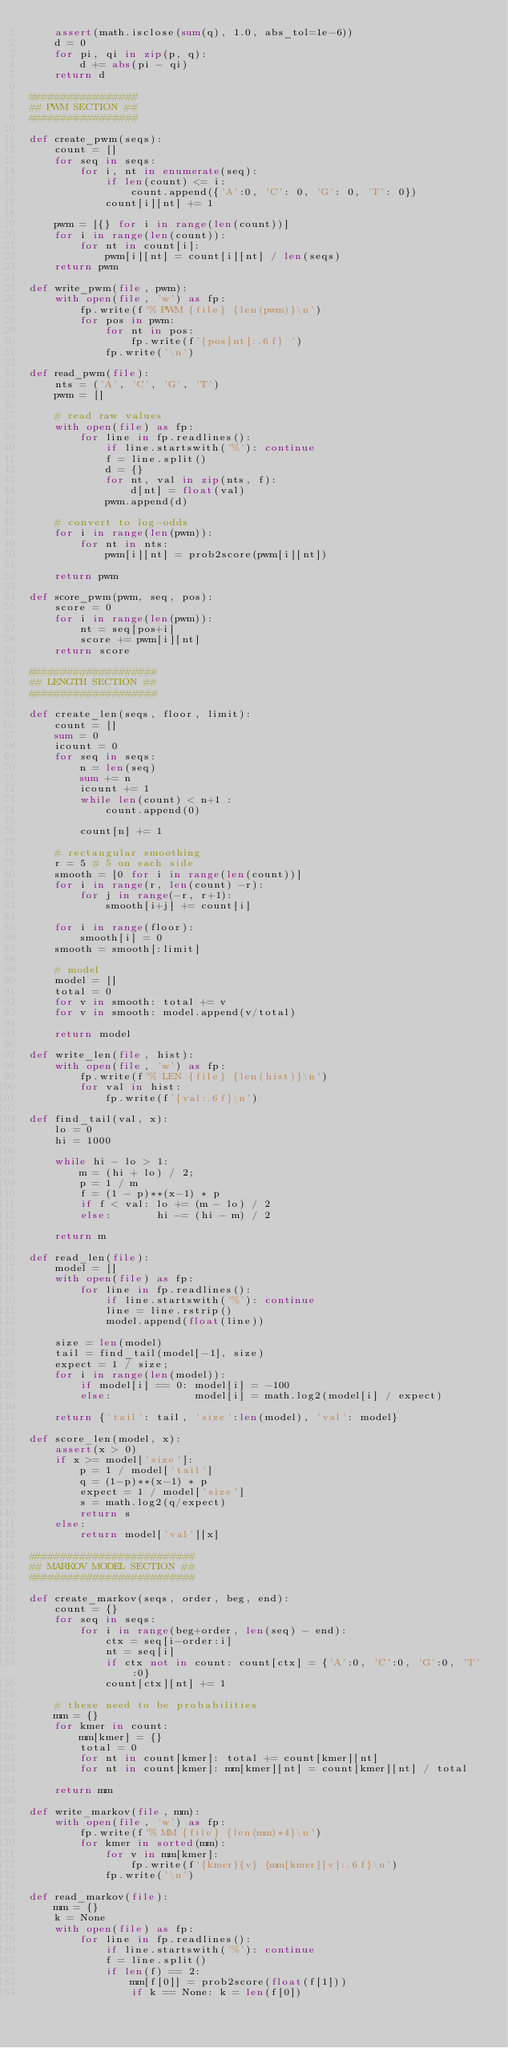Convert code to text. <code><loc_0><loc_0><loc_500><loc_500><_Python_>	assert(math.isclose(sum(q), 1.0, abs_tol=1e-6))
	d = 0
	for pi, qi in zip(p, q):
		d += abs(pi - qi)
	return d

#################
## PWM SECTION ##
#################

def create_pwm(seqs):
	count = []
	for seq in seqs:
		for i, nt in enumerate(seq):
			if len(count) <= i:
				count.append({'A':0, 'C': 0, 'G': 0, 'T': 0})
			count[i][nt] += 1

	pwm = [{} for i in range(len(count))]
	for i in range(len(count)):
		for nt in count[i]:
			pwm[i][nt] = count[i][nt] / len(seqs)
	return pwm

def write_pwm(file, pwm):
	with open(file, 'w') as fp:
		fp.write(f'% PWM {file} {len(pwm)}\n')
		for pos in pwm:
			for nt in pos:
				fp.write(f'{pos[nt]:.6f} ')
			fp.write('\n')

def read_pwm(file):
	nts = ('A', 'C', 'G', 'T')
	pwm = []

	# read raw values
	with open(file) as fp:
		for line in fp.readlines():
			if line.startswith('%'): continue
			f = line.split()
			d = {}
			for nt, val in zip(nts, f):
				d[nt] = float(val)
			pwm.append(d)

	# convert to log-odds
	for i in range(len(pwm)):
		for nt in nts:
			pwm[i][nt] = prob2score(pwm[i][nt])

	return pwm

def score_pwm(pwm, seq, pos):
	score = 0
	for i in range(len(pwm)):
		nt = seq[pos+i]
		score += pwm[i][nt]
	return score

####################
## LENGTH SECTION ##
####################

def create_len(seqs, floor, limit):
	count = []
	sum = 0
	icount = 0
	for seq in seqs:
		n = len(seq)
		sum += n
		icount += 1
		while len(count) < n+1 :
			count.append(0)

		count[n] += 1

	# rectangular smoothing
	r = 5 # 5 on each side
	smooth = [0 for i in range(len(count))]
	for i in range(r, len(count) -r):
		for j in range(-r, r+1):
			smooth[i+j] += count[i]

	for i in range(floor):
		smooth[i] = 0
	smooth = smooth[:limit]

	# model
	model = []
	total = 0
	for v in smooth: total += v
	for v in smooth: model.append(v/total)

	return model

def write_len(file, hist):
	with open(file, 'w') as fp:
		fp.write(f'% LEN {file} {len(hist)}\n')
		for val in hist:
			fp.write(f'{val:.6f}\n')

def find_tail(val, x):
	lo = 0
	hi = 1000

	while hi - lo > 1:
		m = (hi + lo) / 2;
		p = 1 / m
		f = (1 - p)**(x-1) * p
		if f < val: lo += (m - lo) / 2
		else:       hi -= (hi - m) / 2

	return m

def read_len(file):
	model = []
	with open(file) as fp:
		for line in fp.readlines():
			if line.startswith('%'): continue
			line = line.rstrip()
			model.append(float(line))

	size = len(model)
	tail = find_tail(model[-1], size)
	expect = 1 / size;
	for i in range(len(model)):
		if model[i] == 0: model[i] = -100
		else:             model[i] = math.log2(model[i] / expect)

	return {'tail': tail, 'size':len(model), 'val': model}

def score_len(model, x):
	assert(x > 0)
	if x >= model['size']:
		p = 1 / model['tail']
		q = (1-p)**(x-1) * p
		expect = 1 / model['size']
		s = math.log2(q/expect)
		return s
	else:
		return model['val'][x]

##########################
## MARKOV MODEL SECTION ##
##########################

def create_markov(seqs, order, beg, end):
	count = {}
	for seq in seqs:
		for i in range(beg+order, len(seq) - end):
			ctx = seq[i-order:i]
			nt = seq[i]
			if ctx not in count: count[ctx] = {'A':0, 'C':0, 'G':0, 'T':0}
			count[ctx][nt] += 1

	# these need to be probabilities
	mm = {}
	for kmer in count:
		mm[kmer] = {}
		total = 0
		for nt in count[kmer]: total += count[kmer][nt]
		for nt in count[kmer]: mm[kmer][nt] = count[kmer][nt] / total

	return mm

def write_markov(file, mm):
	with open(file, 'w') as fp:
		fp.write(f'% MM {file} {len(mm)*4}\n')
		for kmer in sorted(mm):
			for v in mm[kmer]:
				fp.write(f'{kmer}{v} {mm[kmer][v]:.6f}\n')
			fp.write('\n')

def read_markov(file):
	mm = {}
	k = None
	with open(file) as fp:
		for line in fp.readlines():
			if line.startswith('%'): continue
			f = line.split()
			if len(f) == 2:
				mm[f[0]] = prob2score(float(f[1]))
				if k == None: k = len(f[0])</code> 